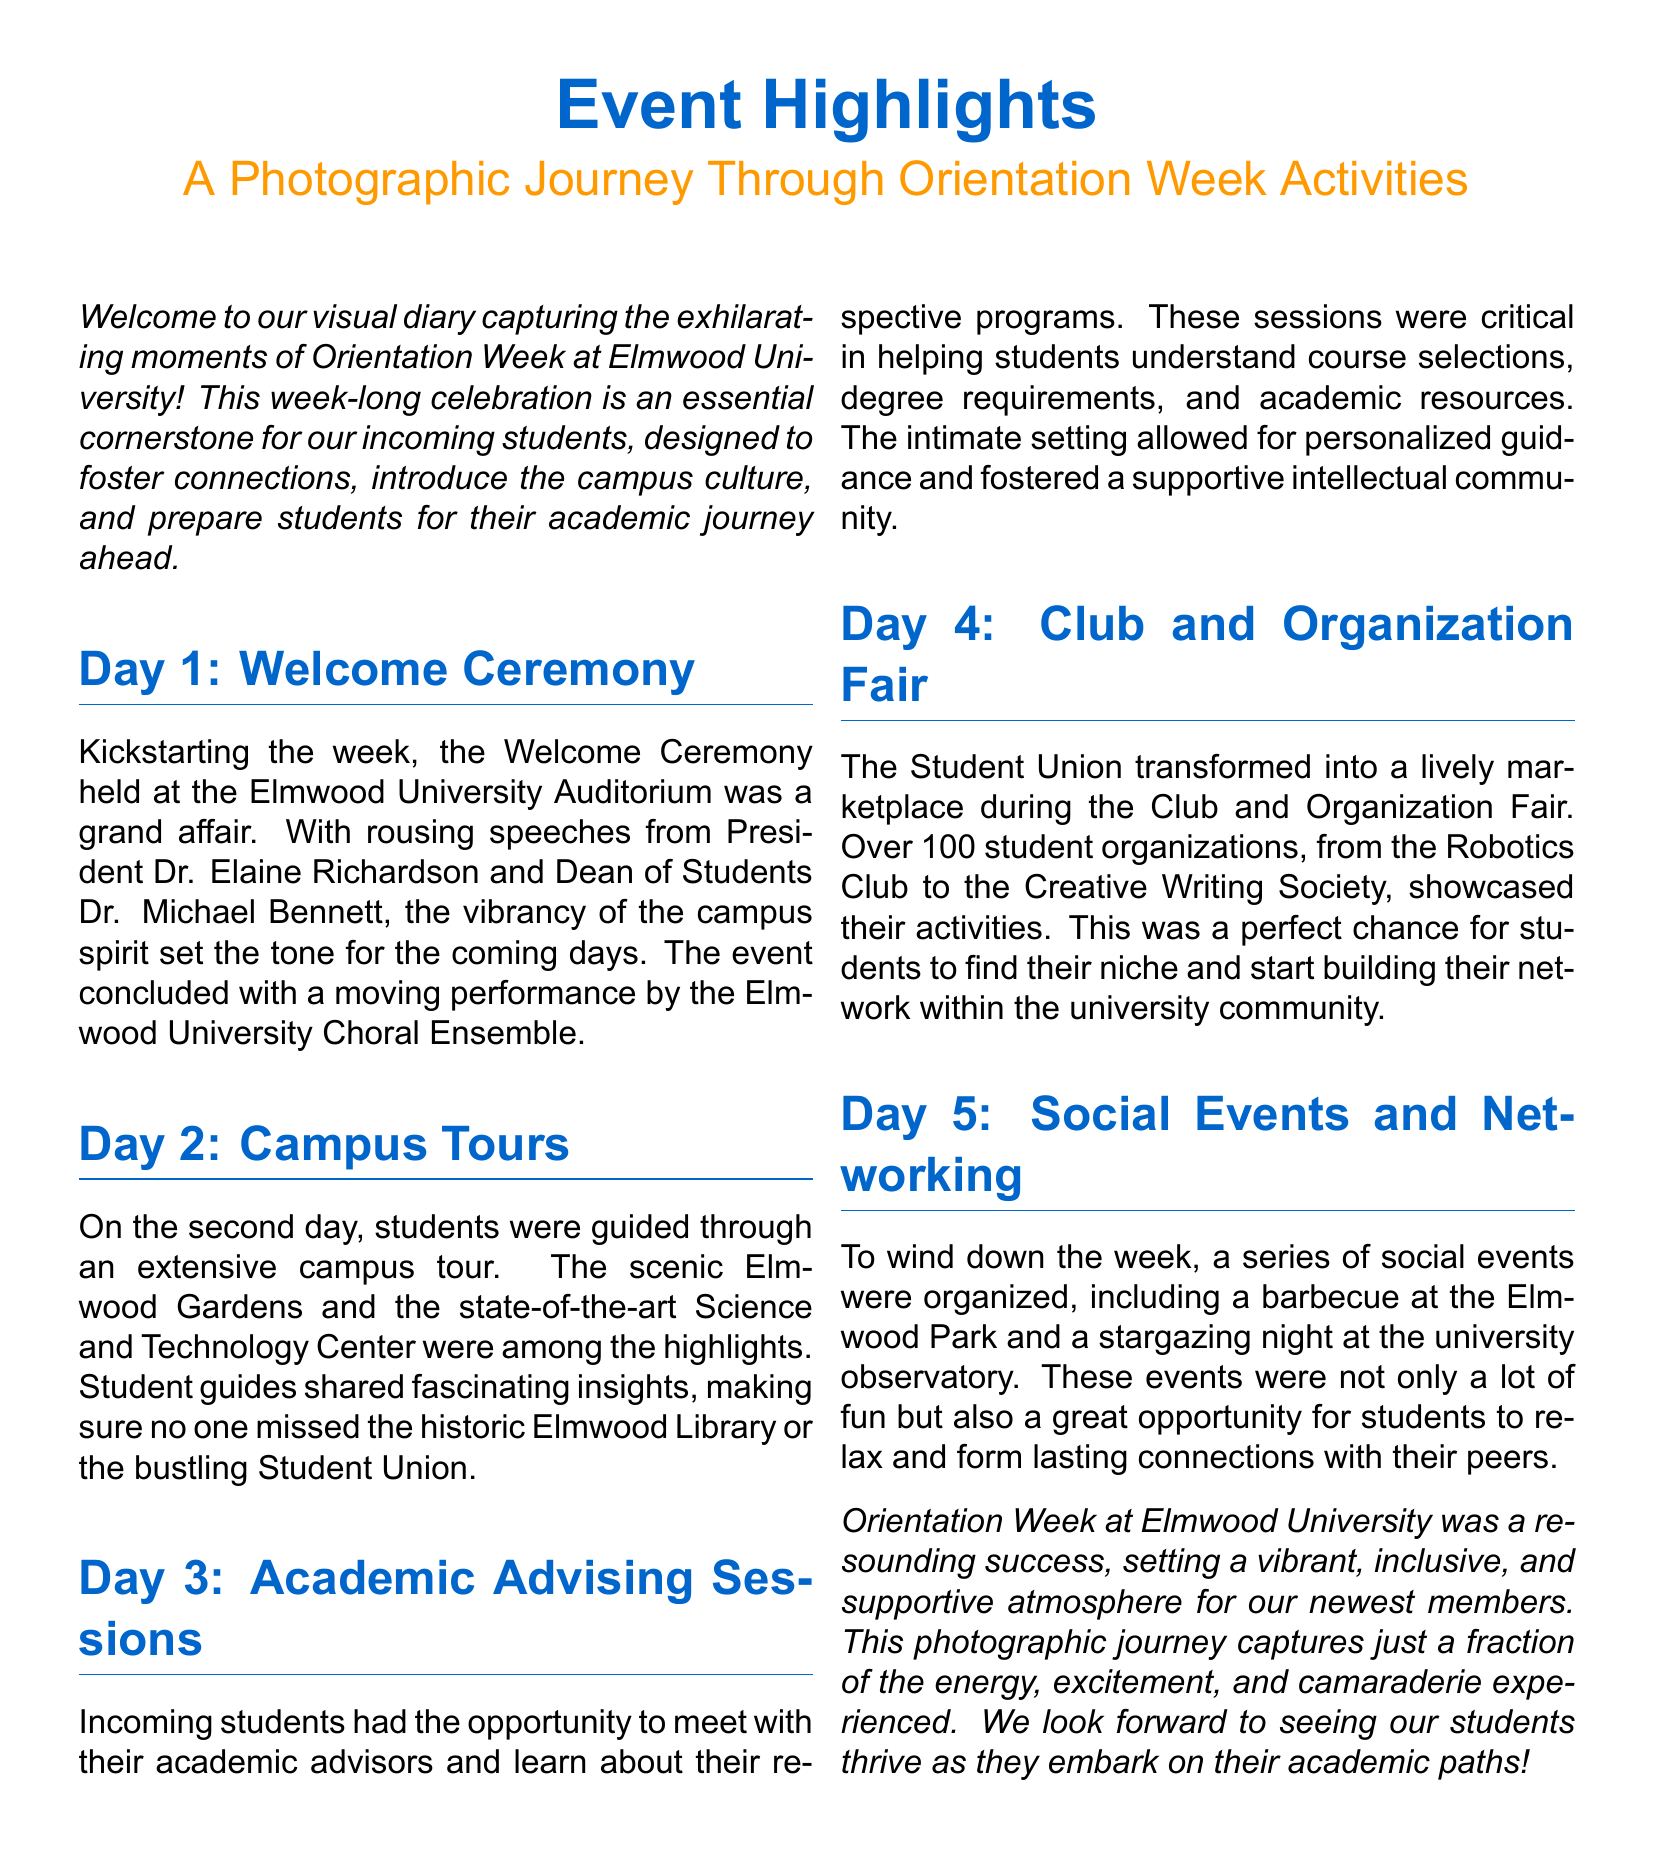What is the title of the event highlights section? The title of the event highlights section is "Event Highlights".
Answer: Event Highlights Who gave speeches during the Welcome Ceremony? The speeches during the Welcome Ceremony were given by President Dr. Elaine Richardson and Dean of Students Dr. Michael Bennett.
Answer: Dr. Elaine Richardson and Dr. Michael Bennett What activity occurred on Day 2? On Day 2, students participated in campus tours.
Answer: Campus Tours How many student organizations were showcased at the Club and Organization Fair? The Club and Organization Fair showcased over 100 student organizations.
Answer: Over 100 What type of events were organized on Day 5? On Day 5, social events and networking activities were organized.
Answer: Social events and networking What was one of the highlights during the campus tour? One of the highlights during the campus tour was the scenic Elmwood Gardens.
Answer: Elmwood Gardens What is the atmosphere described for Orientation Week? The atmosphere described for Orientation Week is vibrant, inclusive, and supportive.
Answer: Vibrant, inclusive, and supportive What performance concluded the Welcome Ceremony? The performance that concluded the Welcome Ceremony was by the Elmwood University Choral Ensemble.
Answer: Elmwood University Choral Ensemble 